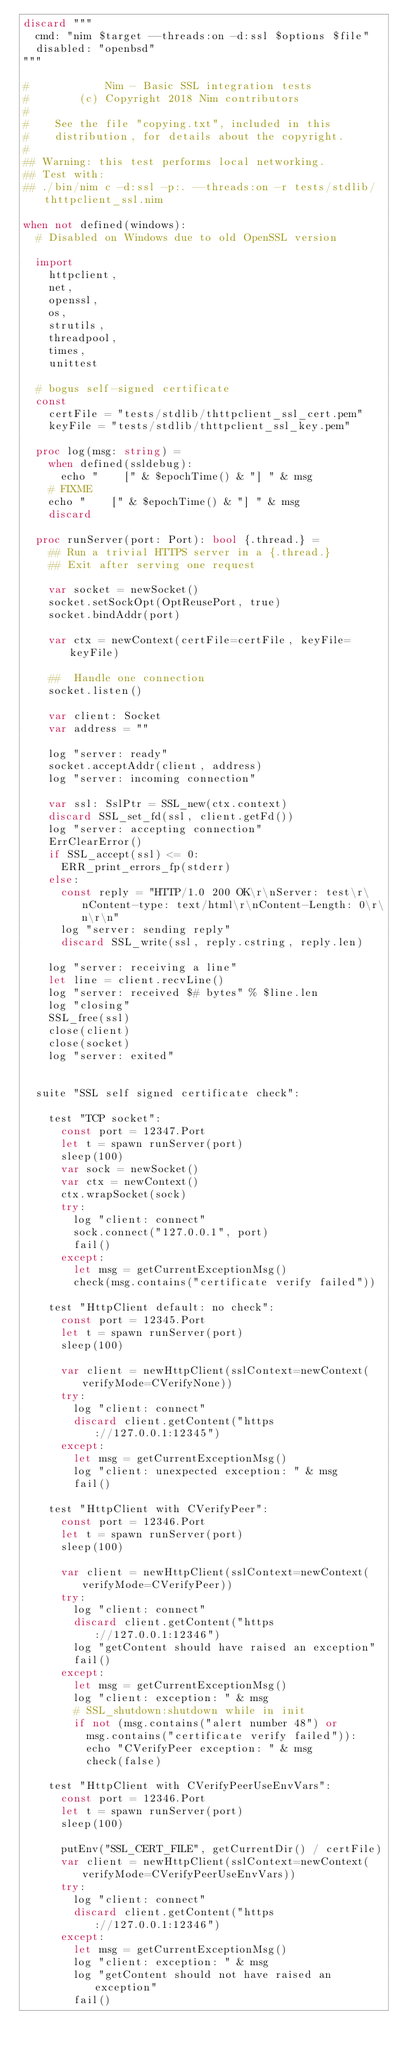Convert code to text. <code><loc_0><loc_0><loc_500><loc_500><_Nim_>discard """
  cmd: "nim $target --threads:on -d:ssl $options $file"
  disabled: "openbsd"
"""

#            Nim - Basic SSL integration tests
#        (c) Copyright 2018 Nim contributors
#
#    See the file "copying.txt", included in this
#    distribution, for details about the copyright.
#
## Warning: this test performs local networking.
## Test with:
## ./bin/nim c -d:ssl -p:. --threads:on -r tests/stdlib/thttpclient_ssl.nim

when not defined(windows):
  # Disabled on Windows due to old OpenSSL version

  import
    httpclient,
    net,
    openssl,
    os,
    strutils,
    threadpool,
    times,
    unittest

  # bogus self-signed certificate
  const
    certFile = "tests/stdlib/thttpclient_ssl_cert.pem"
    keyFile = "tests/stdlib/thttpclient_ssl_key.pem"

  proc log(msg: string) =
    when defined(ssldebug):
      echo "    [" & $epochTime() & "] " & msg
    # FIXME
    echo "    [" & $epochTime() & "] " & msg
    discard

  proc runServer(port: Port): bool {.thread.} =
    ## Run a trivial HTTPS server in a {.thread.}
    ## Exit after serving one request

    var socket = newSocket()
    socket.setSockOpt(OptReusePort, true)
    socket.bindAddr(port)

    var ctx = newContext(certFile=certFile, keyFile=keyFile)

    ##  Handle one connection
    socket.listen()

    var client: Socket
    var address = ""

    log "server: ready"
    socket.acceptAddr(client, address)
    log "server: incoming connection"

    var ssl: SslPtr = SSL_new(ctx.context)
    discard SSL_set_fd(ssl, client.getFd())
    log "server: accepting connection"
    ErrClearError()
    if SSL_accept(ssl) <= 0:
      ERR_print_errors_fp(stderr)
    else:
      const reply = "HTTP/1.0 200 OK\r\nServer: test\r\nContent-type: text/html\r\nContent-Length: 0\r\n\r\n"
      log "server: sending reply"
      discard SSL_write(ssl, reply.cstring, reply.len)

    log "server: receiving a line"
    let line = client.recvLine()
    log "server: received $# bytes" % $line.len
    log "closing"
    SSL_free(ssl)
    close(client)
    close(socket)
    log "server: exited"


  suite "SSL self signed certificate check":

    test "TCP socket":
      const port = 12347.Port
      let t = spawn runServer(port)
      sleep(100)
      var sock = newSocket()
      var ctx = newContext()
      ctx.wrapSocket(sock)
      try:
        log "client: connect"
        sock.connect("127.0.0.1", port)
        fail()
      except:
        let msg = getCurrentExceptionMsg()
        check(msg.contains("certificate verify failed"))

    test "HttpClient default: no check":
      const port = 12345.Port
      let t = spawn runServer(port)
      sleep(100)

      var client = newHttpClient(sslContext=newContext(verifyMode=CVerifyNone))
      try:
        log "client: connect"
        discard client.getContent("https://127.0.0.1:12345")
      except:
        let msg = getCurrentExceptionMsg()
        log "client: unexpected exception: " & msg
        fail()

    test "HttpClient with CVerifyPeer":
      const port = 12346.Port
      let t = spawn runServer(port)
      sleep(100)

      var client = newHttpClient(sslContext=newContext(verifyMode=CVerifyPeer))
      try:
        log "client: connect"
        discard client.getContent("https://127.0.0.1:12346")
        log "getContent should have raised an exception"
        fail()
      except:
        let msg = getCurrentExceptionMsg()
        log "client: exception: " & msg
        # SSL_shutdown:shutdown while in init
        if not (msg.contains("alert number 48") or
          msg.contains("certificate verify failed")):
          echo "CVerifyPeer exception: " & msg
          check(false)

    test "HttpClient with CVerifyPeerUseEnvVars":
      const port = 12346.Port
      let t = spawn runServer(port)
      sleep(100)

      putEnv("SSL_CERT_FILE", getCurrentDir() / certFile)
      var client = newHttpClient(sslContext=newContext(verifyMode=CVerifyPeerUseEnvVars))
      try:
        log "client: connect"
        discard client.getContent("https://127.0.0.1:12346")
      except:
        let msg = getCurrentExceptionMsg()
        log "client: exception: " & msg
        log "getContent should not have raised an exception"
        fail()
</code> 